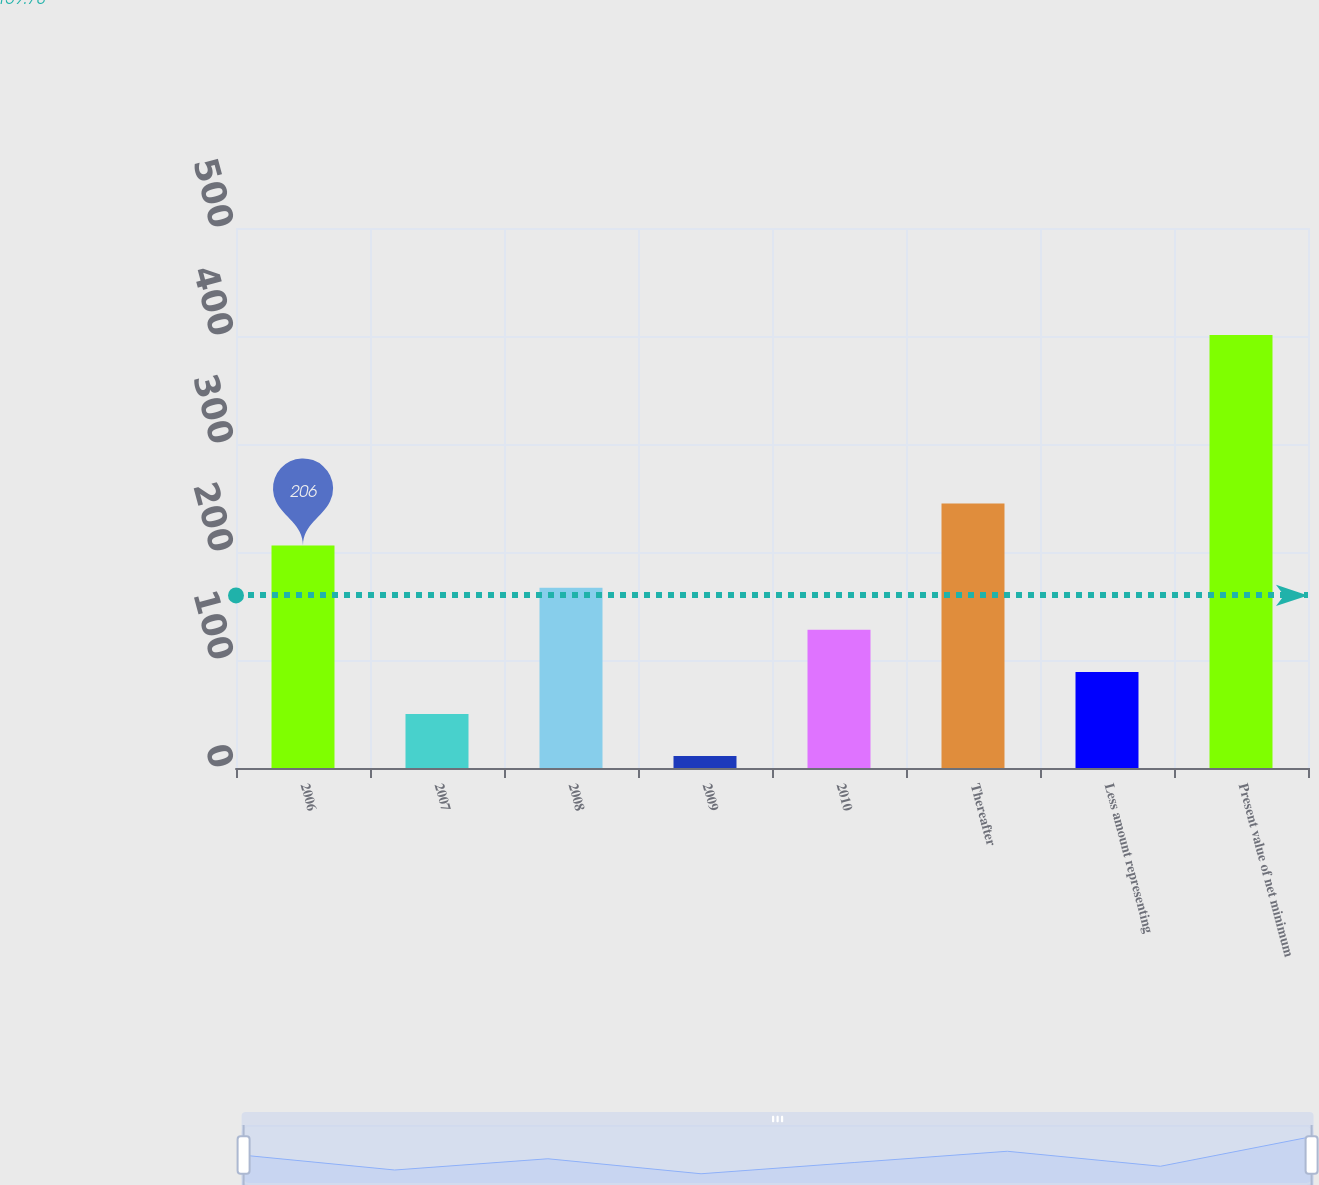<chart> <loc_0><loc_0><loc_500><loc_500><bar_chart><fcel>2006<fcel>2007<fcel>2008<fcel>2009<fcel>2010<fcel>Thereafter<fcel>Less amount representing<fcel>Present value of net minimum<nl><fcel>206<fcel>50<fcel>167<fcel>11<fcel>128<fcel>245<fcel>89<fcel>401<nl></chart> 